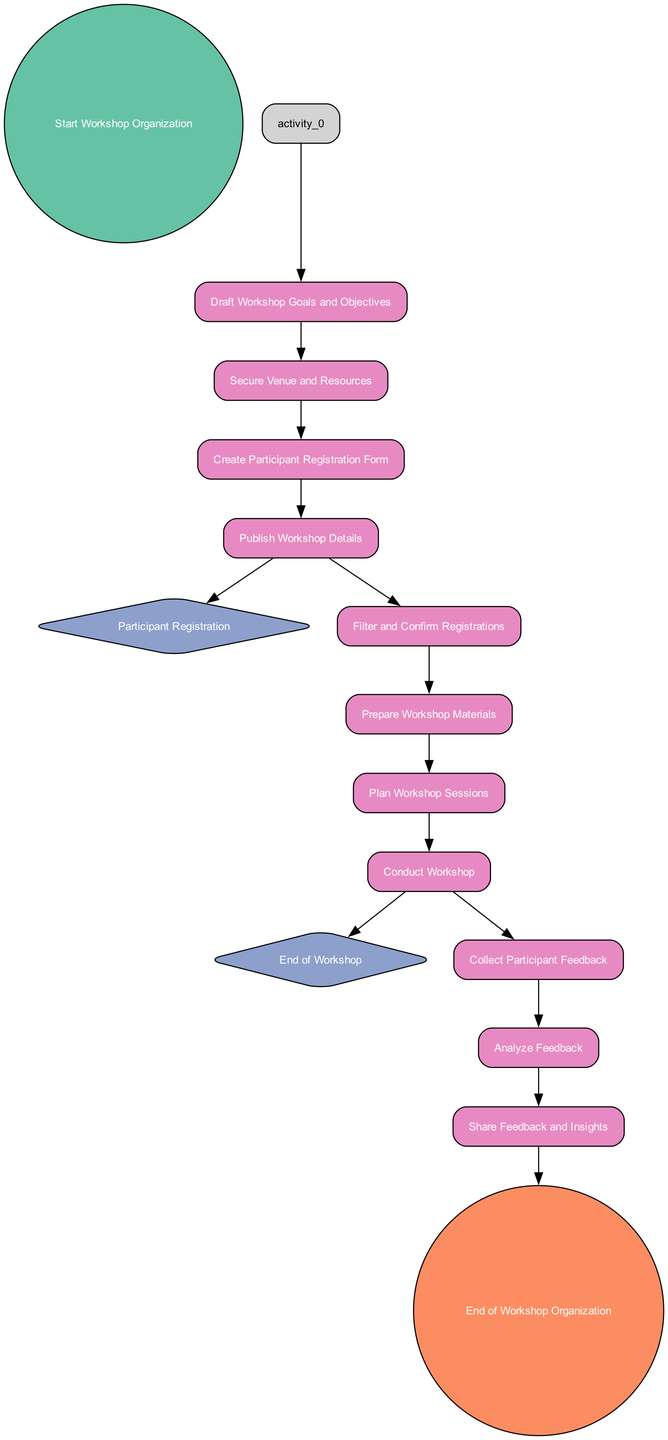What is the first activity in the diagram? The first activity node that follows the start event, "Start Workshop Organization," is "Draft Workshop Goals and Objectives." It is identified as the first activity that initiates the workflow in the diagram.
Answer: Draft Workshop Goals and Objectives How many activities are there in total? The diagram contains ten activity nodes including the session planning steps, which are "Draft Workshop Goals and Objectives," "Secure Venue and Resources," "Create Participant Registration Form," "Filter and Confirm Registrations," "Prepare Workshop Materials," "Plan Workshop Sessions," "Conduct Workshop," "Collect Participant Feedback," "Analyze Feedback," and "Share Feedback and Insights." This counts to a total of 10 activities.
Answer: 10 What is the last activity before the end event? The last activity that proceeds before reaching the end event, "End of Workshop Organization," is "Share Feedback and Insights." This indicates it’s the final step in the workflow that leads to the conclusion.
Answer: Share Feedback and Insights What type of events are represented in the diagram? The diagram includes one start event, two intermediate events, and one end event. This structure defines the beginning, progression, and conclusion of the workshop organization process.
Answer: Start, Intermediate, and End events What is the relationship between "Collect Participant Feedback" and "Analyze Feedback"? "Collect Participant Feedback" directly precedes "Analyze Feedback" in the workflow. This shows that once feedback is collected from participants, the next logical step is to analyze the feedback for insights.
Answer: Directly precedes How many registration steps are there? The registration process includes "Create Participant Registration Form" and "Filter and Confirm Registrations," indicating there are two key steps involved in managing participant registrations.
Answer: Two steps Which activity immediately follows "Prepare Workshop Materials"? The activity that comes right after "Prepare Workshop Materials" is "Plan Workshop Sessions." This reflects the sequential nature of preparing materials as a precursor to session planning.
Answer: Plan Workshop Sessions What is the role of the intermediate event "Participant Registration"? The intermediate event "Participant Registration" serves as a transition point in the diagram, indicating that the process of registering participants occurs before filtering and confirming their registrations. It acts as a checkpoint in the workflow.
Answer: Transition point What do the colors in the diagram represent? The colors in the diagram differentiate between types of nodes: start events are green, end events are red, intermediate events are blue, and activities are pink. This color coding helps to quickly identify the purpose of each node.
Answer: Different types of nodes 